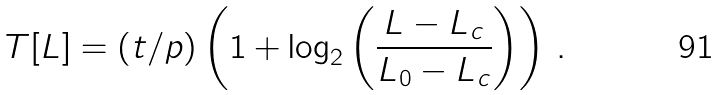<formula> <loc_0><loc_0><loc_500><loc_500>T [ L ] = ( t / p ) \left ( 1 + \log _ { 2 } \left ( \frac { L - L _ { c } } { L _ { 0 } - L _ { c } } \right ) \right ) \, .</formula> 